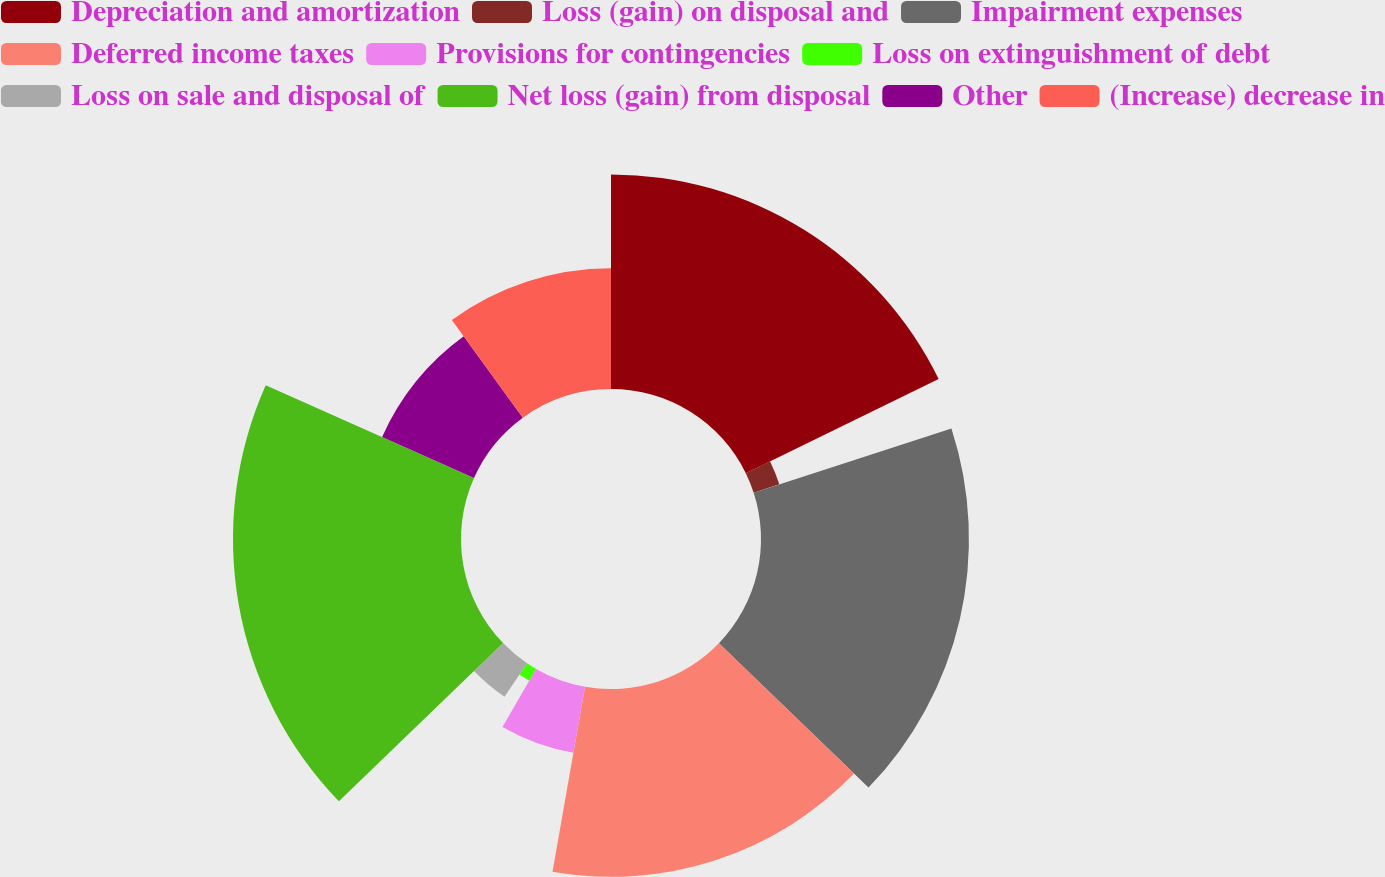Convert chart. <chart><loc_0><loc_0><loc_500><loc_500><pie_chart><fcel>Depreciation and amortization<fcel>Loss (gain) on disposal and<fcel>Impairment expenses<fcel>Deferred income taxes<fcel>Provisions for contingencies<fcel>Loss on extinguishment of debt<fcel>Loss on sale and disposal of<fcel>Net loss (gain) from disposal<fcel>Other<fcel>(Increase) decrease in<nl><fcel>17.77%<fcel>2.23%<fcel>17.22%<fcel>15.55%<fcel>5.56%<fcel>1.12%<fcel>3.34%<fcel>18.88%<fcel>8.33%<fcel>10.0%<nl></chart> 